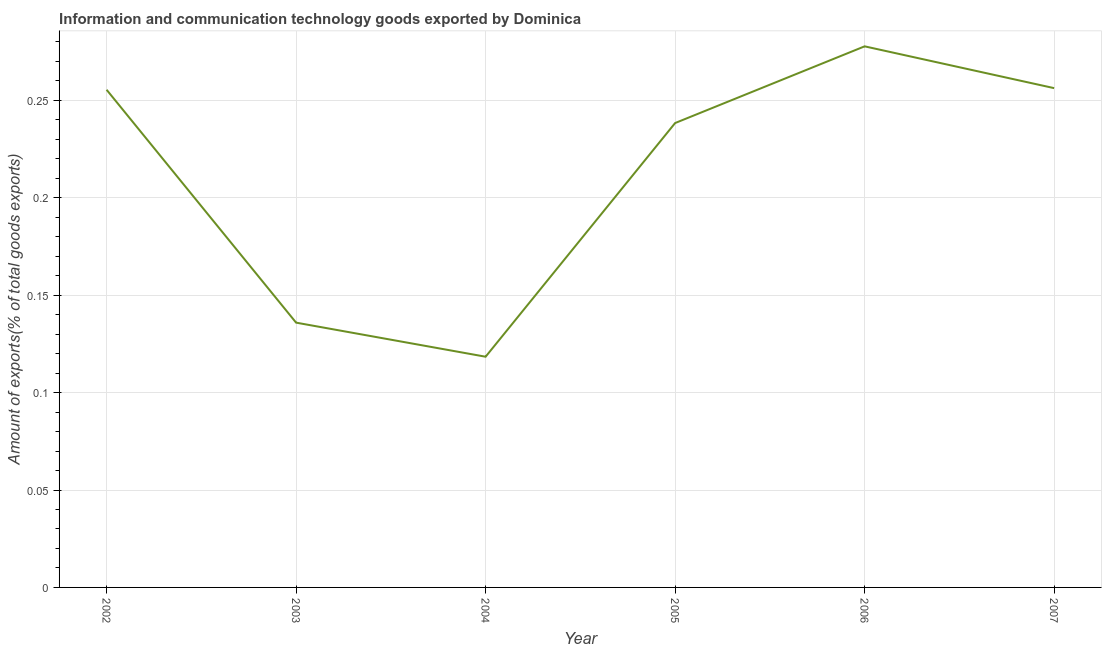What is the amount of ict goods exports in 2007?
Your answer should be very brief. 0.26. Across all years, what is the maximum amount of ict goods exports?
Offer a terse response. 0.28. Across all years, what is the minimum amount of ict goods exports?
Provide a short and direct response. 0.12. In which year was the amount of ict goods exports minimum?
Make the answer very short. 2004. What is the sum of the amount of ict goods exports?
Offer a terse response. 1.28. What is the difference between the amount of ict goods exports in 2003 and 2005?
Keep it short and to the point. -0.1. What is the average amount of ict goods exports per year?
Make the answer very short. 0.21. What is the median amount of ict goods exports?
Offer a very short reply. 0.25. Do a majority of the years between 2003 and 2002 (inclusive) have amount of ict goods exports greater than 0.24000000000000002 %?
Provide a succinct answer. No. What is the ratio of the amount of ict goods exports in 2002 to that in 2004?
Your answer should be compact. 2.16. Is the amount of ict goods exports in 2004 less than that in 2006?
Your answer should be very brief. Yes. Is the difference between the amount of ict goods exports in 2004 and 2007 greater than the difference between any two years?
Give a very brief answer. No. What is the difference between the highest and the second highest amount of ict goods exports?
Your response must be concise. 0.02. Is the sum of the amount of ict goods exports in 2002 and 2005 greater than the maximum amount of ict goods exports across all years?
Provide a short and direct response. Yes. What is the difference between the highest and the lowest amount of ict goods exports?
Your answer should be compact. 0.16. How many years are there in the graph?
Ensure brevity in your answer.  6. What is the difference between two consecutive major ticks on the Y-axis?
Provide a short and direct response. 0.05. Does the graph contain grids?
Give a very brief answer. Yes. What is the title of the graph?
Offer a very short reply. Information and communication technology goods exported by Dominica. What is the label or title of the X-axis?
Provide a succinct answer. Year. What is the label or title of the Y-axis?
Offer a terse response. Amount of exports(% of total goods exports). What is the Amount of exports(% of total goods exports) in 2002?
Keep it short and to the point. 0.26. What is the Amount of exports(% of total goods exports) of 2003?
Offer a very short reply. 0.14. What is the Amount of exports(% of total goods exports) of 2004?
Give a very brief answer. 0.12. What is the Amount of exports(% of total goods exports) of 2005?
Offer a very short reply. 0.24. What is the Amount of exports(% of total goods exports) of 2006?
Offer a terse response. 0.28. What is the Amount of exports(% of total goods exports) in 2007?
Your response must be concise. 0.26. What is the difference between the Amount of exports(% of total goods exports) in 2002 and 2003?
Your response must be concise. 0.12. What is the difference between the Amount of exports(% of total goods exports) in 2002 and 2004?
Your answer should be very brief. 0.14. What is the difference between the Amount of exports(% of total goods exports) in 2002 and 2005?
Your answer should be very brief. 0.02. What is the difference between the Amount of exports(% of total goods exports) in 2002 and 2006?
Offer a terse response. -0.02. What is the difference between the Amount of exports(% of total goods exports) in 2002 and 2007?
Make the answer very short. -0. What is the difference between the Amount of exports(% of total goods exports) in 2003 and 2004?
Make the answer very short. 0.02. What is the difference between the Amount of exports(% of total goods exports) in 2003 and 2005?
Offer a terse response. -0.1. What is the difference between the Amount of exports(% of total goods exports) in 2003 and 2006?
Offer a terse response. -0.14. What is the difference between the Amount of exports(% of total goods exports) in 2003 and 2007?
Provide a short and direct response. -0.12. What is the difference between the Amount of exports(% of total goods exports) in 2004 and 2005?
Make the answer very short. -0.12. What is the difference between the Amount of exports(% of total goods exports) in 2004 and 2006?
Make the answer very short. -0.16. What is the difference between the Amount of exports(% of total goods exports) in 2004 and 2007?
Ensure brevity in your answer.  -0.14. What is the difference between the Amount of exports(% of total goods exports) in 2005 and 2006?
Your answer should be compact. -0.04. What is the difference between the Amount of exports(% of total goods exports) in 2005 and 2007?
Your response must be concise. -0.02. What is the difference between the Amount of exports(% of total goods exports) in 2006 and 2007?
Offer a very short reply. 0.02. What is the ratio of the Amount of exports(% of total goods exports) in 2002 to that in 2003?
Offer a very short reply. 1.88. What is the ratio of the Amount of exports(% of total goods exports) in 2002 to that in 2004?
Provide a short and direct response. 2.16. What is the ratio of the Amount of exports(% of total goods exports) in 2002 to that in 2005?
Offer a terse response. 1.07. What is the ratio of the Amount of exports(% of total goods exports) in 2002 to that in 2006?
Provide a short and direct response. 0.92. What is the ratio of the Amount of exports(% of total goods exports) in 2002 to that in 2007?
Provide a short and direct response. 1. What is the ratio of the Amount of exports(% of total goods exports) in 2003 to that in 2004?
Your response must be concise. 1.15. What is the ratio of the Amount of exports(% of total goods exports) in 2003 to that in 2005?
Offer a terse response. 0.57. What is the ratio of the Amount of exports(% of total goods exports) in 2003 to that in 2006?
Your response must be concise. 0.49. What is the ratio of the Amount of exports(% of total goods exports) in 2003 to that in 2007?
Your answer should be very brief. 0.53. What is the ratio of the Amount of exports(% of total goods exports) in 2004 to that in 2005?
Keep it short and to the point. 0.5. What is the ratio of the Amount of exports(% of total goods exports) in 2004 to that in 2006?
Offer a very short reply. 0.43. What is the ratio of the Amount of exports(% of total goods exports) in 2004 to that in 2007?
Provide a short and direct response. 0.46. What is the ratio of the Amount of exports(% of total goods exports) in 2005 to that in 2006?
Your answer should be compact. 0.86. What is the ratio of the Amount of exports(% of total goods exports) in 2006 to that in 2007?
Keep it short and to the point. 1.08. 